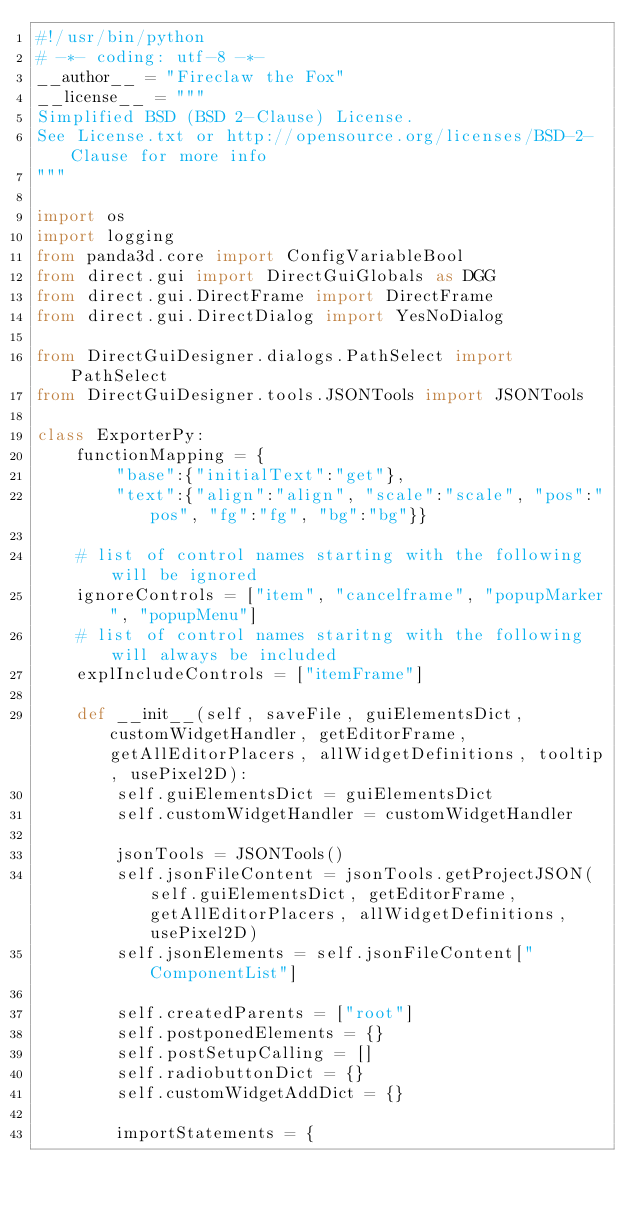<code> <loc_0><loc_0><loc_500><loc_500><_Python_>#!/usr/bin/python
# -*- coding: utf-8 -*-
__author__ = "Fireclaw the Fox"
__license__ = """
Simplified BSD (BSD 2-Clause) License.
See License.txt or http://opensource.org/licenses/BSD-2-Clause for more info
"""

import os
import logging
from panda3d.core import ConfigVariableBool
from direct.gui import DirectGuiGlobals as DGG
from direct.gui.DirectFrame import DirectFrame
from direct.gui.DirectDialog import YesNoDialog

from DirectGuiDesigner.dialogs.PathSelect import PathSelect
from DirectGuiDesigner.tools.JSONTools import JSONTools

class ExporterPy:
    functionMapping = {
        "base":{"initialText":"get"},
        "text":{"align":"align", "scale":"scale", "pos":"pos", "fg":"fg", "bg":"bg"}}

    # list of control names starting with the following will be ignored
    ignoreControls = ["item", "cancelframe", "popupMarker", "popupMenu"]
    # list of control names staritng with the following will always be included
    explIncludeControls = ["itemFrame"]

    def __init__(self, saveFile, guiElementsDict, customWidgetHandler, getEditorFrame, getAllEditorPlacers, allWidgetDefinitions, tooltip, usePixel2D):
        self.guiElementsDict = guiElementsDict
        self.customWidgetHandler = customWidgetHandler

        jsonTools = JSONTools()
        self.jsonFileContent = jsonTools.getProjectJSON(self.guiElementsDict, getEditorFrame, getAllEditorPlacers, allWidgetDefinitions, usePixel2D)
        self.jsonElements = self.jsonFileContent["ComponentList"]

        self.createdParents = ["root"]
        self.postponedElements = {}
        self.postSetupCalling = []
        self.radiobuttonDict = {}
        self.customWidgetAddDict = {}

        importStatements = {</code> 